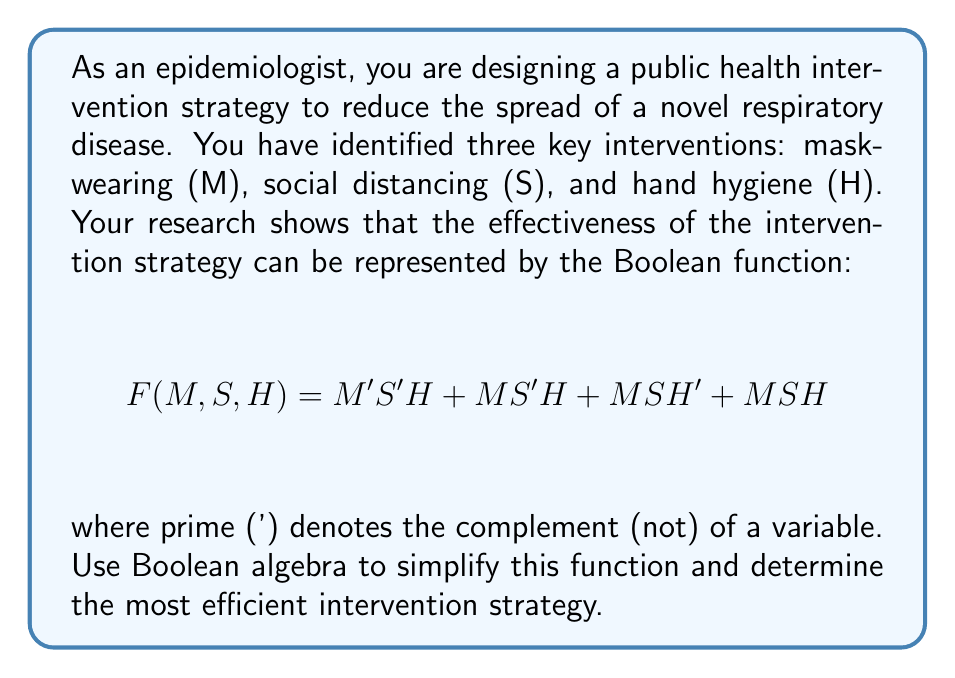Show me your answer to this math problem. Let's simplify the Boolean function step by step:

1) Start with the given function:
   $$F(M,S,H) = M'S'H + MS'H + MSH' + MSH$$

2) Factor out S' from the first two terms and S from the last two terms:
   $$F(M,S,H) = S'H(M' + M) + MS(H' + H)$$

3) Simplify using the identity $A + A' = 1$:
   $$F(M,S,H) = S'H(1) + MS(1)$$

4) Remove the parentheses:
   $$F(M,S,H) = S'H + MS$$

5) This is the simplified form. We can interpret this as follows:
   - The intervention strategy is effective when either:
     a) Social distancing is not implemented (S') AND hand hygiene (H) is practiced, OR
     b) Mask-wearing (M) AND social distancing (S) are implemented.

6) This suggests that hand hygiene can compensate for a lack of social distancing, but if social distancing is implemented, mask-wearing should also be implemented for the strategy to be effective.
Answer: $$F(M,S,H) = S'H + MS$$ 